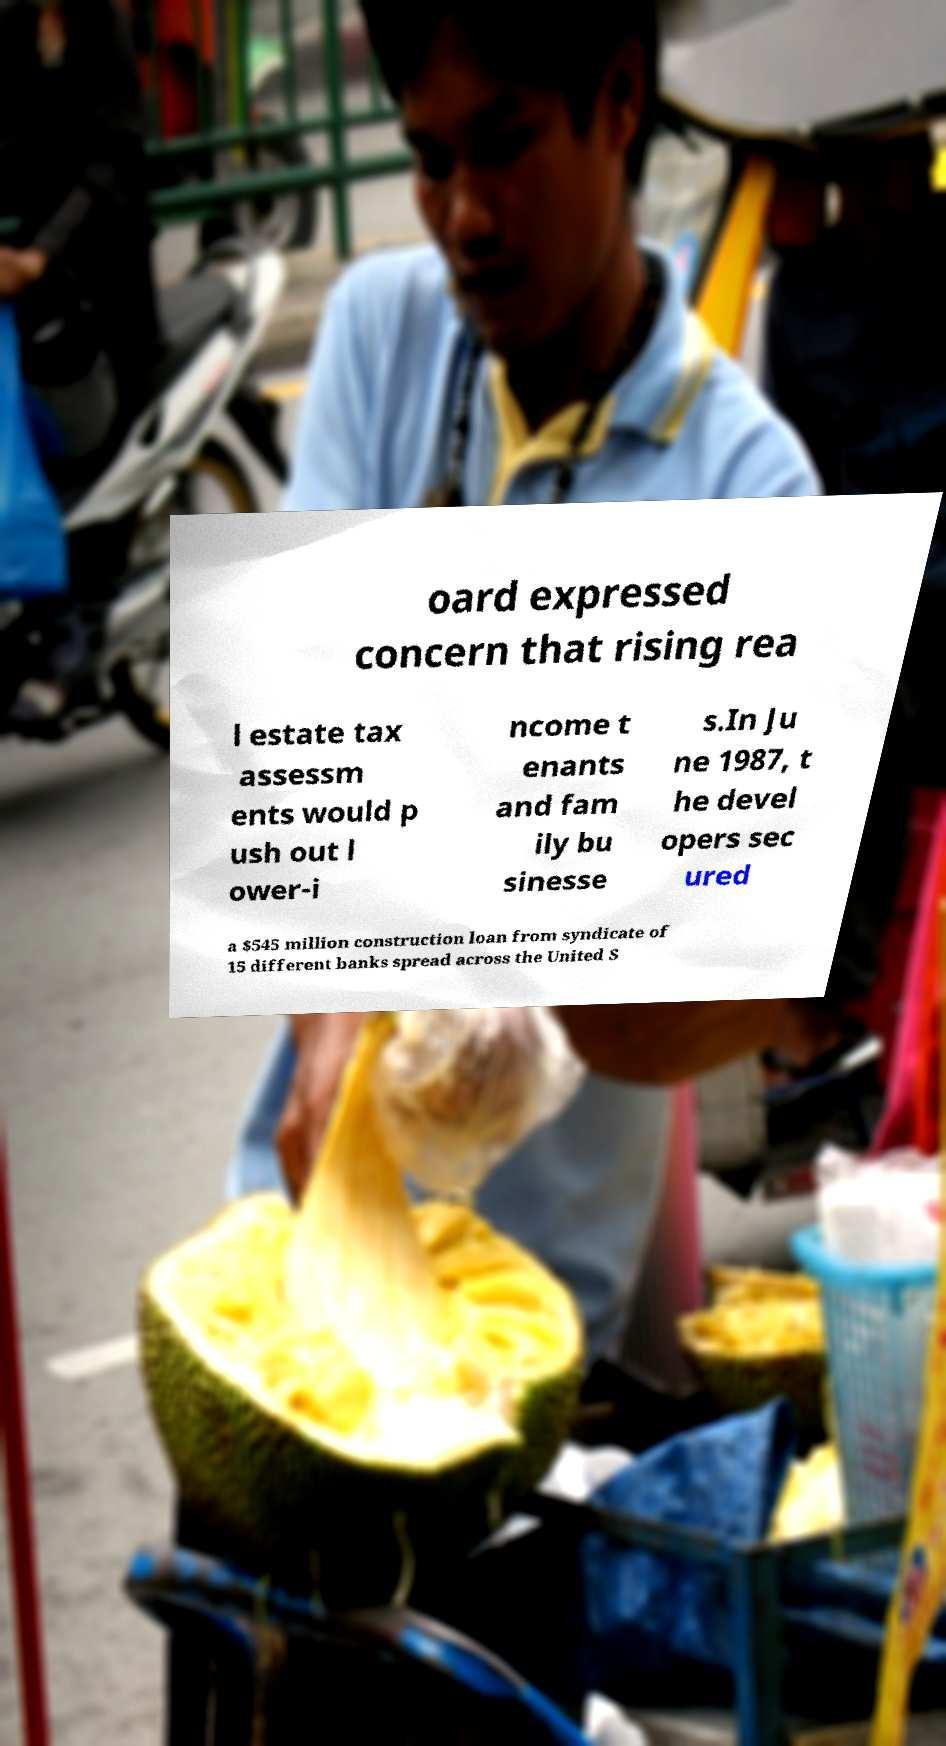Can you read and provide the text displayed in the image?This photo seems to have some interesting text. Can you extract and type it out for me? oard expressed concern that rising rea l estate tax assessm ents would p ush out l ower-i ncome t enants and fam ily bu sinesse s.In Ju ne 1987, t he devel opers sec ured a $545 million construction loan from syndicate of 15 different banks spread across the United S 